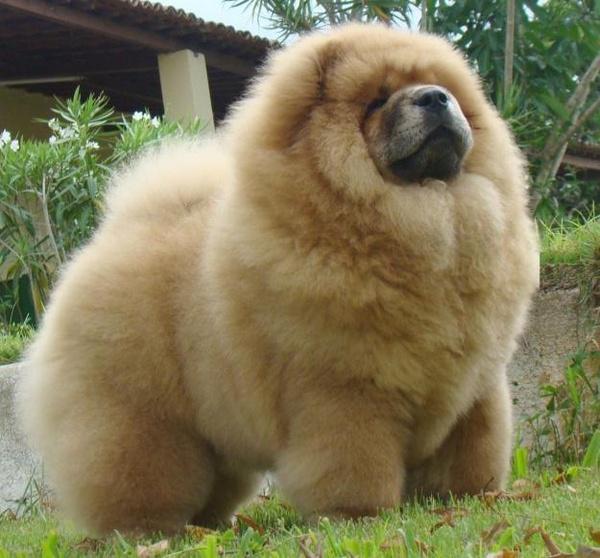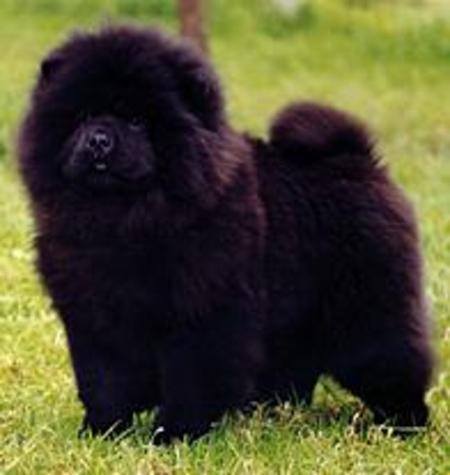The first image is the image on the left, the second image is the image on the right. For the images displayed, is the sentence "The right image contains one adult red-orange chow standing in profile turned leftward, and the left image includes a fluffy young chow facing forward." factually correct? Answer yes or no. No. The first image is the image on the left, the second image is the image on the right. Analyze the images presented: Is the assertion "The left image contains one black chow dog." valid? Answer yes or no. No. 